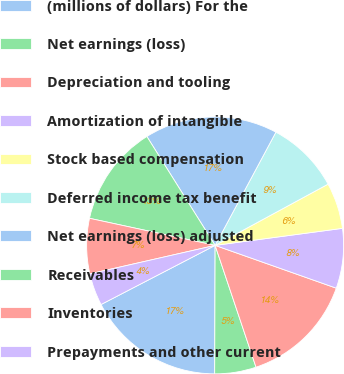<chart> <loc_0><loc_0><loc_500><loc_500><pie_chart><fcel>(millions of dollars) For the<fcel>Net earnings (loss)<fcel>Depreciation and tooling<fcel>Amortization of intangible<fcel>Stock based compensation<fcel>Deferred income tax benefit<fcel>Net earnings (loss) adjusted<fcel>Receivables<fcel>Inventories<fcel>Prepayments and other current<nl><fcel>17.33%<fcel>5.21%<fcel>14.44%<fcel>7.52%<fcel>5.79%<fcel>9.25%<fcel>16.75%<fcel>12.71%<fcel>6.94%<fcel>4.05%<nl></chart> 